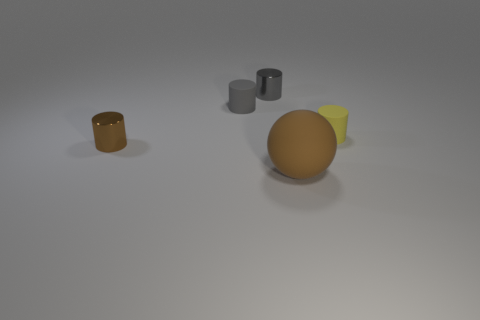There is a brown object behind the large brown matte ball; what is its material?
Your response must be concise. Metal. Are the gray cylinder that is in front of the small gray shiny cylinder and the brown cylinder made of the same material?
Offer a terse response. No. What number of other objects are the same material as the small brown object?
Your answer should be very brief. 1. There is a brown metallic thing; are there any gray metal things right of it?
Make the answer very short. Yes. Is the size of the brown metallic cylinder the same as the yellow thing?
Your answer should be compact. Yes. There is a gray metallic object that is the same shape as the yellow matte object; what size is it?
Make the answer very short. Small. Is there anything else that is the same size as the gray matte object?
Ensure brevity in your answer.  Yes. What is the material of the tiny cylinder in front of the object right of the big brown object?
Provide a short and direct response. Metal. Does the tiny yellow object have the same shape as the gray matte thing?
Offer a terse response. Yes. What number of objects are both in front of the small gray shiny object and right of the gray matte object?
Your answer should be compact. 2. 